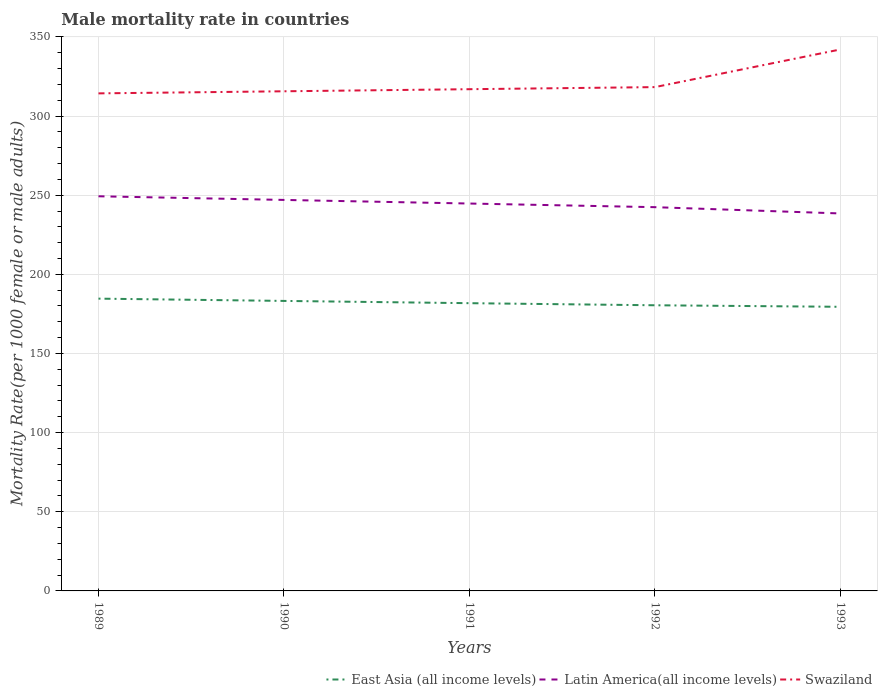Is the number of lines equal to the number of legend labels?
Give a very brief answer. Yes. Across all years, what is the maximum male mortality rate in East Asia (all income levels)?
Make the answer very short. 179.49. What is the total male mortality rate in East Asia (all income levels) in the graph?
Your response must be concise. 3.71. What is the difference between the highest and the second highest male mortality rate in East Asia (all income levels)?
Offer a very short reply. 5.15. What is the difference between the highest and the lowest male mortality rate in Latin America(all income levels)?
Give a very brief answer. 3. How many years are there in the graph?
Give a very brief answer. 5. Are the values on the major ticks of Y-axis written in scientific E-notation?
Offer a very short reply. No. Does the graph contain any zero values?
Give a very brief answer. No. Where does the legend appear in the graph?
Make the answer very short. Bottom right. What is the title of the graph?
Your answer should be compact. Male mortality rate in countries. Does "Niger" appear as one of the legend labels in the graph?
Offer a terse response. No. What is the label or title of the Y-axis?
Provide a short and direct response. Mortality Rate(per 1000 female or male adults). What is the Mortality Rate(per 1000 female or male adults) in East Asia (all income levels) in 1989?
Provide a short and direct response. 184.64. What is the Mortality Rate(per 1000 female or male adults) in Latin America(all income levels) in 1989?
Your response must be concise. 249.3. What is the Mortality Rate(per 1000 female or male adults) of Swaziland in 1989?
Your response must be concise. 314.31. What is the Mortality Rate(per 1000 female or male adults) in East Asia (all income levels) in 1990?
Give a very brief answer. 183.2. What is the Mortality Rate(per 1000 female or male adults) of Latin America(all income levels) in 1990?
Offer a very short reply. 247. What is the Mortality Rate(per 1000 female or male adults) in Swaziland in 1990?
Give a very brief answer. 315.63. What is the Mortality Rate(per 1000 female or male adults) in East Asia (all income levels) in 1991?
Offer a very short reply. 181.77. What is the Mortality Rate(per 1000 female or male adults) in Latin America(all income levels) in 1991?
Keep it short and to the point. 244.72. What is the Mortality Rate(per 1000 female or male adults) of Swaziland in 1991?
Your response must be concise. 316.95. What is the Mortality Rate(per 1000 female or male adults) of East Asia (all income levels) in 1992?
Provide a succinct answer. 180.45. What is the Mortality Rate(per 1000 female or male adults) in Latin America(all income levels) in 1992?
Ensure brevity in your answer.  242.42. What is the Mortality Rate(per 1000 female or male adults) of Swaziland in 1992?
Give a very brief answer. 318.27. What is the Mortality Rate(per 1000 female or male adults) of East Asia (all income levels) in 1993?
Offer a terse response. 179.49. What is the Mortality Rate(per 1000 female or male adults) of Latin America(all income levels) in 1993?
Offer a very short reply. 238.46. What is the Mortality Rate(per 1000 female or male adults) of Swaziland in 1993?
Your response must be concise. 342.06. Across all years, what is the maximum Mortality Rate(per 1000 female or male adults) of East Asia (all income levels)?
Provide a succinct answer. 184.64. Across all years, what is the maximum Mortality Rate(per 1000 female or male adults) of Latin America(all income levels)?
Your response must be concise. 249.3. Across all years, what is the maximum Mortality Rate(per 1000 female or male adults) of Swaziland?
Your answer should be compact. 342.06. Across all years, what is the minimum Mortality Rate(per 1000 female or male adults) of East Asia (all income levels)?
Your answer should be very brief. 179.49. Across all years, what is the minimum Mortality Rate(per 1000 female or male adults) of Latin America(all income levels)?
Your answer should be compact. 238.46. Across all years, what is the minimum Mortality Rate(per 1000 female or male adults) in Swaziland?
Give a very brief answer. 314.31. What is the total Mortality Rate(per 1000 female or male adults) of East Asia (all income levels) in the graph?
Your answer should be very brief. 909.55. What is the total Mortality Rate(per 1000 female or male adults) in Latin America(all income levels) in the graph?
Offer a terse response. 1221.9. What is the total Mortality Rate(per 1000 female or male adults) in Swaziland in the graph?
Make the answer very short. 1607.22. What is the difference between the Mortality Rate(per 1000 female or male adults) in East Asia (all income levels) in 1989 and that in 1990?
Offer a very short reply. 1.44. What is the difference between the Mortality Rate(per 1000 female or male adults) of Latin America(all income levels) in 1989 and that in 1990?
Provide a succinct answer. 2.31. What is the difference between the Mortality Rate(per 1000 female or male adults) in Swaziland in 1989 and that in 1990?
Your answer should be compact. -1.32. What is the difference between the Mortality Rate(per 1000 female or male adults) of East Asia (all income levels) in 1989 and that in 1991?
Your response must be concise. 2.87. What is the difference between the Mortality Rate(per 1000 female or male adults) in Latin America(all income levels) in 1989 and that in 1991?
Keep it short and to the point. 4.58. What is the difference between the Mortality Rate(per 1000 female or male adults) in Swaziland in 1989 and that in 1991?
Your answer should be compact. -2.63. What is the difference between the Mortality Rate(per 1000 female or male adults) of East Asia (all income levels) in 1989 and that in 1992?
Your answer should be very brief. 4.19. What is the difference between the Mortality Rate(per 1000 female or male adults) of Latin America(all income levels) in 1989 and that in 1992?
Your response must be concise. 6.88. What is the difference between the Mortality Rate(per 1000 female or male adults) in Swaziland in 1989 and that in 1992?
Ensure brevity in your answer.  -3.95. What is the difference between the Mortality Rate(per 1000 female or male adults) of East Asia (all income levels) in 1989 and that in 1993?
Keep it short and to the point. 5.15. What is the difference between the Mortality Rate(per 1000 female or male adults) of Latin America(all income levels) in 1989 and that in 1993?
Ensure brevity in your answer.  10.85. What is the difference between the Mortality Rate(per 1000 female or male adults) of Swaziland in 1989 and that in 1993?
Give a very brief answer. -27.75. What is the difference between the Mortality Rate(per 1000 female or male adults) of East Asia (all income levels) in 1990 and that in 1991?
Keep it short and to the point. 1.43. What is the difference between the Mortality Rate(per 1000 female or male adults) in Latin America(all income levels) in 1990 and that in 1991?
Provide a short and direct response. 2.28. What is the difference between the Mortality Rate(per 1000 female or male adults) in Swaziland in 1990 and that in 1991?
Make the answer very short. -1.32. What is the difference between the Mortality Rate(per 1000 female or male adults) in East Asia (all income levels) in 1990 and that in 1992?
Keep it short and to the point. 2.75. What is the difference between the Mortality Rate(per 1000 female or male adults) in Latin America(all income levels) in 1990 and that in 1992?
Your answer should be very brief. 4.58. What is the difference between the Mortality Rate(per 1000 female or male adults) in Swaziland in 1990 and that in 1992?
Provide a short and direct response. -2.63. What is the difference between the Mortality Rate(per 1000 female or male adults) of East Asia (all income levels) in 1990 and that in 1993?
Your response must be concise. 3.71. What is the difference between the Mortality Rate(per 1000 female or male adults) of Latin America(all income levels) in 1990 and that in 1993?
Keep it short and to the point. 8.54. What is the difference between the Mortality Rate(per 1000 female or male adults) in Swaziland in 1990 and that in 1993?
Make the answer very short. -26.43. What is the difference between the Mortality Rate(per 1000 female or male adults) of East Asia (all income levels) in 1991 and that in 1992?
Keep it short and to the point. 1.32. What is the difference between the Mortality Rate(per 1000 female or male adults) of Latin America(all income levels) in 1991 and that in 1992?
Give a very brief answer. 2.3. What is the difference between the Mortality Rate(per 1000 female or male adults) in Swaziland in 1991 and that in 1992?
Offer a terse response. -1.32. What is the difference between the Mortality Rate(per 1000 female or male adults) of East Asia (all income levels) in 1991 and that in 1993?
Ensure brevity in your answer.  2.28. What is the difference between the Mortality Rate(per 1000 female or male adults) in Latin America(all income levels) in 1991 and that in 1993?
Make the answer very short. 6.26. What is the difference between the Mortality Rate(per 1000 female or male adults) of Swaziland in 1991 and that in 1993?
Offer a very short reply. -25.11. What is the difference between the Mortality Rate(per 1000 female or male adults) in East Asia (all income levels) in 1992 and that in 1993?
Your answer should be compact. 0.96. What is the difference between the Mortality Rate(per 1000 female or male adults) of Latin America(all income levels) in 1992 and that in 1993?
Ensure brevity in your answer.  3.97. What is the difference between the Mortality Rate(per 1000 female or male adults) in Swaziland in 1992 and that in 1993?
Offer a very short reply. -23.8. What is the difference between the Mortality Rate(per 1000 female or male adults) in East Asia (all income levels) in 1989 and the Mortality Rate(per 1000 female or male adults) in Latin America(all income levels) in 1990?
Keep it short and to the point. -62.36. What is the difference between the Mortality Rate(per 1000 female or male adults) in East Asia (all income levels) in 1989 and the Mortality Rate(per 1000 female or male adults) in Swaziland in 1990?
Make the answer very short. -130.99. What is the difference between the Mortality Rate(per 1000 female or male adults) of Latin America(all income levels) in 1989 and the Mortality Rate(per 1000 female or male adults) of Swaziland in 1990?
Offer a terse response. -66.33. What is the difference between the Mortality Rate(per 1000 female or male adults) in East Asia (all income levels) in 1989 and the Mortality Rate(per 1000 female or male adults) in Latin America(all income levels) in 1991?
Offer a very short reply. -60.08. What is the difference between the Mortality Rate(per 1000 female or male adults) in East Asia (all income levels) in 1989 and the Mortality Rate(per 1000 female or male adults) in Swaziland in 1991?
Provide a succinct answer. -132.31. What is the difference between the Mortality Rate(per 1000 female or male adults) of Latin America(all income levels) in 1989 and the Mortality Rate(per 1000 female or male adults) of Swaziland in 1991?
Ensure brevity in your answer.  -67.65. What is the difference between the Mortality Rate(per 1000 female or male adults) in East Asia (all income levels) in 1989 and the Mortality Rate(per 1000 female or male adults) in Latin America(all income levels) in 1992?
Make the answer very short. -57.78. What is the difference between the Mortality Rate(per 1000 female or male adults) in East Asia (all income levels) in 1989 and the Mortality Rate(per 1000 female or male adults) in Swaziland in 1992?
Your response must be concise. -133.63. What is the difference between the Mortality Rate(per 1000 female or male adults) of Latin America(all income levels) in 1989 and the Mortality Rate(per 1000 female or male adults) of Swaziland in 1992?
Provide a succinct answer. -68.96. What is the difference between the Mortality Rate(per 1000 female or male adults) of East Asia (all income levels) in 1989 and the Mortality Rate(per 1000 female or male adults) of Latin America(all income levels) in 1993?
Offer a terse response. -53.82. What is the difference between the Mortality Rate(per 1000 female or male adults) of East Asia (all income levels) in 1989 and the Mortality Rate(per 1000 female or male adults) of Swaziland in 1993?
Provide a short and direct response. -157.42. What is the difference between the Mortality Rate(per 1000 female or male adults) in Latin America(all income levels) in 1989 and the Mortality Rate(per 1000 female or male adults) in Swaziland in 1993?
Your answer should be compact. -92.76. What is the difference between the Mortality Rate(per 1000 female or male adults) of East Asia (all income levels) in 1990 and the Mortality Rate(per 1000 female or male adults) of Latin America(all income levels) in 1991?
Make the answer very short. -61.52. What is the difference between the Mortality Rate(per 1000 female or male adults) in East Asia (all income levels) in 1990 and the Mortality Rate(per 1000 female or male adults) in Swaziland in 1991?
Your answer should be very brief. -133.75. What is the difference between the Mortality Rate(per 1000 female or male adults) in Latin America(all income levels) in 1990 and the Mortality Rate(per 1000 female or male adults) in Swaziland in 1991?
Your response must be concise. -69.95. What is the difference between the Mortality Rate(per 1000 female or male adults) in East Asia (all income levels) in 1990 and the Mortality Rate(per 1000 female or male adults) in Latin America(all income levels) in 1992?
Provide a succinct answer. -59.22. What is the difference between the Mortality Rate(per 1000 female or male adults) in East Asia (all income levels) in 1990 and the Mortality Rate(per 1000 female or male adults) in Swaziland in 1992?
Provide a succinct answer. -135.06. What is the difference between the Mortality Rate(per 1000 female or male adults) in Latin America(all income levels) in 1990 and the Mortality Rate(per 1000 female or male adults) in Swaziland in 1992?
Your response must be concise. -71.27. What is the difference between the Mortality Rate(per 1000 female or male adults) of East Asia (all income levels) in 1990 and the Mortality Rate(per 1000 female or male adults) of Latin America(all income levels) in 1993?
Make the answer very short. -55.25. What is the difference between the Mortality Rate(per 1000 female or male adults) in East Asia (all income levels) in 1990 and the Mortality Rate(per 1000 female or male adults) in Swaziland in 1993?
Offer a very short reply. -158.86. What is the difference between the Mortality Rate(per 1000 female or male adults) of Latin America(all income levels) in 1990 and the Mortality Rate(per 1000 female or male adults) of Swaziland in 1993?
Offer a terse response. -95.06. What is the difference between the Mortality Rate(per 1000 female or male adults) in East Asia (all income levels) in 1991 and the Mortality Rate(per 1000 female or male adults) in Latin America(all income levels) in 1992?
Keep it short and to the point. -60.65. What is the difference between the Mortality Rate(per 1000 female or male adults) of East Asia (all income levels) in 1991 and the Mortality Rate(per 1000 female or male adults) of Swaziland in 1992?
Give a very brief answer. -136.49. What is the difference between the Mortality Rate(per 1000 female or male adults) of Latin America(all income levels) in 1991 and the Mortality Rate(per 1000 female or male adults) of Swaziland in 1992?
Offer a very short reply. -73.55. What is the difference between the Mortality Rate(per 1000 female or male adults) in East Asia (all income levels) in 1991 and the Mortality Rate(per 1000 female or male adults) in Latin America(all income levels) in 1993?
Offer a terse response. -56.68. What is the difference between the Mortality Rate(per 1000 female or male adults) in East Asia (all income levels) in 1991 and the Mortality Rate(per 1000 female or male adults) in Swaziland in 1993?
Give a very brief answer. -160.29. What is the difference between the Mortality Rate(per 1000 female or male adults) of Latin America(all income levels) in 1991 and the Mortality Rate(per 1000 female or male adults) of Swaziland in 1993?
Make the answer very short. -97.34. What is the difference between the Mortality Rate(per 1000 female or male adults) in East Asia (all income levels) in 1992 and the Mortality Rate(per 1000 female or male adults) in Latin America(all income levels) in 1993?
Keep it short and to the point. -58. What is the difference between the Mortality Rate(per 1000 female or male adults) of East Asia (all income levels) in 1992 and the Mortality Rate(per 1000 female or male adults) of Swaziland in 1993?
Make the answer very short. -161.61. What is the difference between the Mortality Rate(per 1000 female or male adults) of Latin America(all income levels) in 1992 and the Mortality Rate(per 1000 female or male adults) of Swaziland in 1993?
Provide a short and direct response. -99.64. What is the average Mortality Rate(per 1000 female or male adults) of East Asia (all income levels) per year?
Offer a terse response. 181.91. What is the average Mortality Rate(per 1000 female or male adults) of Latin America(all income levels) per year?
Provide a short and direct response. 244.38. What is the average Mortality Rate(per 1000 female or male adults) in Swaziland per year?
Offer a very short reply. 321.44. In the year 1989, what is the difference between the Mortality Rate(per 1000 female or male adults) in East Asia (all income levels) and Mortality Rate(per 1000 female or male adults) in Latin America(all income levels)?
Make the answer very short. -64.66. In the year 1989, what is the difference between the Mortality Rate(per 1000 female or male adults) of East Asia (all income levels) and Mortality Rate(per 1000 female or male adults) of Swaziland?
Your answer should be very brief. -129.67. In the year 1989, what is the difference between the Mortality Rate(per 1000 female or male adults) of Latin America(all income levels) and Mortality Rate(per 1000 female or male adults) of Swaziland?
Give a very brief answer. -65.01. In the year 1990, what is the difference between the Mortality Rate(per 1000 female or male adults) of East Asia (all income levels) and Mortality Rate(per 1000 female or male adults) of Latin America(all income levels)?
Your answer should be compact. -63.8. In the year 1990, what is the difference between the Mortality Rate(per 1000 female or male adults) in East Asia (all income levels) and Mortality Rate(per 1000 female or male adults) in Swaziland?
Keep it short and to the point. -132.43. In the year 1990, what is the difference between the Mortality Rate(per 1000 female or male adults) of Latin America(all income levels) and Mortality Rate(per 1000 female or male adults) of Swaziland?
Ensure brevity in your answer.  -68.63. In the year 1991, what is the difference between the Mortality Rate(per 1000 female or male adults) of East Asia (all income levels) and Mortality Rate(per 1000 female or male adults) of Latin America(all income levels)?
Provide a succinct answer. -62.95. In the year 1991, what is the difference between the Mortality Rate(per 1000 female or male adults) of East Asia (all income levels) and Mortality Rate(per 1000 female or male adults) of Swaziland?
Offer a terse response. -135.18. In the year 1991, what is the difference between the Mortality Rate(per 1000 female or male adults) in Latin America(all income levels) and Mortality Rate(per 1000 female or male adults) in Swaziland?
Provide a short and direct response. -72.23. In the year 1992, what is the difference between the Mortality Rate(per 1000 female or male adults) in East Asia (all income levels) and Mortality Rate(per 1000 female or male adults) in Latin America(all income levels)?
Offer a very short reply. -61.97. In the year 1992, what is the difference between the Mortality Rate(per 1000 female or male adults) of East Asia (all income levels) and Mortality Rate(per 1000 female or male adults) of Swaziland?
Your answer should be compact. -137.81. In the year 1992, what is the difference between the Mortality Rate(per 1000 female or male adults) in Latin America(all income levels) and Mortality Rate(per 1000 female or male adults) in Swaziland?
Your answer should be compact. -75.84. In the year 1993, what is the difference between the Mortality Rate(per 1000 female or male adults) of East Asia (all income levels) and Mortality Rate(per 1000 female or male adults) of Latin America(all income levels)?
Offer a very short reply. -58.97. In the year 1993, what is the difference between the Mortality Rate(per 1000 female or male adults) in East Asia (all income levels) and Mortality Rate(per 1000 female or male adults) in Swaziland?
Offer a very short reply. -162.57. In the year 1993, what is the difference between the Mortality Rate(per 1000 female or male adults) in Latin America(all income levels) and Mortality Rate(per 1000 female or male adults) in Swaziland?
Give a very brief answer. -103.61. What is the ratio of the Mortality Rate(per 1000 female or male adults) in East Asia (all income levels) in 1989 to that in 1990?
Provide a short and direct response. 1.01. What is the ratio of the Mortality Rate(per 1000 female or male adults) in Latin America(all income levels) in 1989 to that in 1990?
Keep it short and to the point. 1.01. What is the ratio of the Mortality Rate(per 1000 female or male adults) of East Asia (all income levels) in 1989 to that in 1991?
Your answer should be compact. 1.02. What is the ratio of the Mortality Rate(per 1000 female or male adults) in Latin America(all income levels) in 1989 to that in 1991?
Offer a terse response. 1.02. What is the ratio of the Mortality Rate(per 1000 female or male adults) in East Asia (all income levels) in 1989 to that in 1992?
Your answer should be compact. 1.02. What is the ratio of the Mortality Rate(per 1000 female or male adults) in Latin America(all income levels) in 1989 to that in 1992?
Keep it short and to the point. 1.03. What is the ratio of the Mortality Rate(per 1000 female or male adults) in Swaziland in 1989 to that in 1992?
Offer a very short reply. 0.99. What is the ratio of the Mortality Rate(per 1000 female or male adults) in East Asia (all income levels) in 1989 to that in 1993?
Make the answer very short. 1.03. What is the ratio of the Mortality Rate(per 1000 female or male adults) of Latin America(all income levels) in 1989 to that in 1993?
Your answer should be compact. 1.05. What is the ratio of the Mortality Rate(per 1000 female or male adults) in Swaziland in 1989 to that in 1993?
Your response must be concise. 0.92. What is the ratio of the Mortality Rate(per 1000 female or male adults) in East Asia (all income levels) in 1990 to that in 1991?
Your answer should be compact. 1.01. What is the ratio of the Mortality Rate(per 1000 female or male adults) of Latin America(all income levels) in 1990 to that in 1991?
Provide a short and direct response. 1.01. What is the ratio of the Mortality Rate(per 1000 female or male adults) in Swaziland in 1990 to that in 1991?
Your answer should be compact. 1. What is the ratio of the Mortality Rate(per 1000 female or male adults) of East Asia (all income levels) in 1990 to that in 1992?
Your response must be concise. 1.02. What is the ratio of the Mortality Rate(per 1000 female or male adults) in Latin America(all income levels) in 1990 to that in 1992?
Give a very brief answer. 1.02. What is the ratio of the Mortality Rate(per 1000 female or male adults) of Swaziland in 1990 to that in 1992?
Make the answer very short. 0.99. What is the ratio of the Mortality Rate(per 1000 female or male adults) in East Asia (all income levels) in 1990 to that in 1993?
Your answer should be compact. 1.02. What is the ratio of the Mortality Rate(per 1000 female or male adults) of Latin America(all income levels) in 1990 to that in 1993?
Offer a terse response. 1.04. What is the ratio of the Mortality Rate(per 1000 female or male adults) of Swaziland in 1990 to that in 1993?
Make the answer very short. 0.92. What is the ratio of the Mortality Rate(per 1000 female or male adults) of East Asia (all income levels) in 1991 to that in 1992?
Provide a succinct answer. 1.01. What is the ratio of the Mortality Rate(per 1000 female or male adults) of Latin America(all income levels) in 1991 to that in 1992?
Your answer should be very brief. 1.01. What is the ratio of the Mortality Rate(per 1000 female or male adults) of Swaziland in 1991 to that in 1992?
Keep it short and to the point. 1. What is the ratio of the Mortality Rate(per 1000 female or male adults) of East Asia (all income levels) in 1991 to that in 1993?
Your answer should be compact. 1.01. What is the ratio of the Mortality Rate(per 1000 female or male adults) in Latin America(all income levels) in 1991 to that in 1993?
Your answer should be very brief. 1.03. What is the ratio of the Mortality Rate(per 1000 female or male adults) in Swaziland in 1991 to that in 1993?
Offer a terse response. 0.93. What is the ratio of the Mortality Rate(per 1000 female or male adults) of East Asia (all income levels) in 1992 to that in 1993?
Offer a very short reply. 1.01. What is the ratio of the Mortality Rate(per 1000 female or male adults) of Latin America(all income levels) in 1992 to that in 1993?
Ensure brevity in your answer.  1.02. What is the ratio of the Mortality Rate(per 1000 female or male adults) of Swaziland in 1992 to that in 1993?
Provide a succinct answer. 0.93. What is the difference between the highest and the second highest Mortality Rate(per 1000 female or male adults) in East Asia (all income levels)?
Offer a terse response. 1.44. What is the difference between the highest and the second highest Mortality Rate(per 1000 female or male adults) of Latin America(all income levels)?
Your answer should be compact. 2.31. What is the difference between the highest and the second highest Mortality Rate(per 1000 female or male adults) of Swaziland?
Provide a succinct answer. 23.8. What is the difference between the highest and the lowest Mortality Rate(per 1000 female or male adults) in East Asia (all income levels)?
Ensure brevity in your answer.  5.15. What is the difference between the highest and the lowest Mortality Rate(per 1000 female or male adults) in Latin America(all income levels)?
Your response must be concise. 10.85. What is the difference between the highest and the lowest Mortality Rate(per 1000 female or male adults) of Swaziland?
Provide a short and direct response. 27.75. 